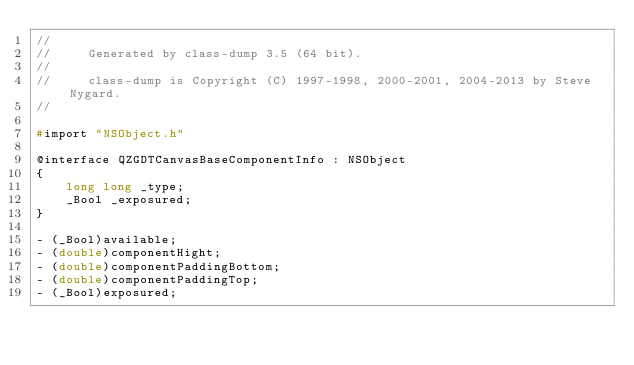<code> <loc_0><loc_0><loc_500><loc_500><_C_>//
//     Generated by class-dump 3.5 (64 bit).
//
//     class-dump is Copyright (C) 1997-1998, 2000-2001, 2004-2013 by Steve Nygard.
//

#import "NSObject.h"

@interface QZGDTCanvasBaseComponentInfo : NSObject
{
    long long _type;
    _Bool _exposured;
}

- (_Bool)available;
- (double)componentHight;
- (double)componentPaddingBottom;
- (double)componentPaddingTop;
- (_Bool)exposured;</code> 